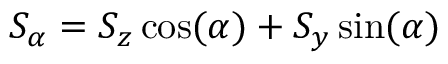Convert formula to latex. <formula><loc_0><loc_0><loc_500><loc_500>{ S _ { \alpha } = { S _ { z } } \cos ( \alpha ) + { S _ { y } } \sin ( \alpha ) }</formula> 